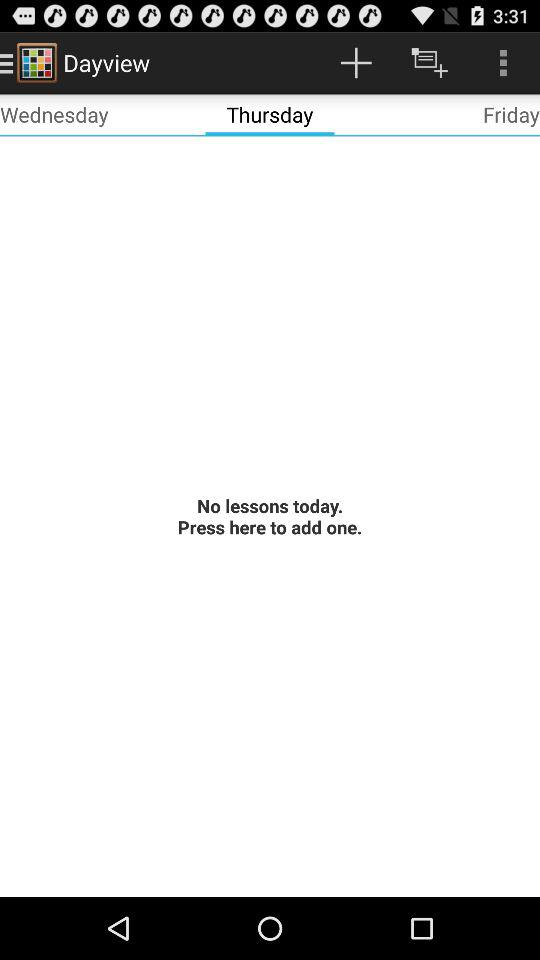Are there any lessons for Thursday? There are no lessons for Thursday. 